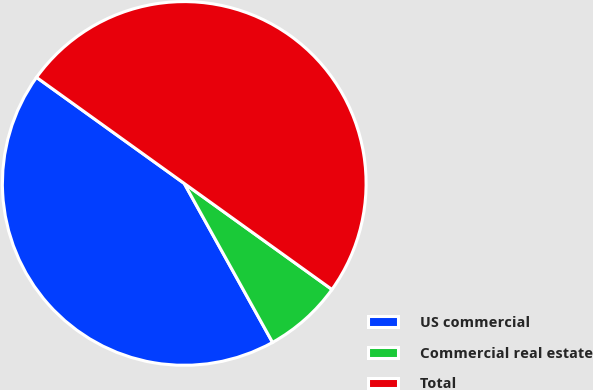Convert chart to OTSL. <chart><loc_0><loc_0><loc_500><loc_500><pie_chart><fcel>US commercial<fcel>Commercial real estate<fcel>Total<nl><fcel>42.98%<fcel>7.02%<fcel>50.0%<nl></chart> 